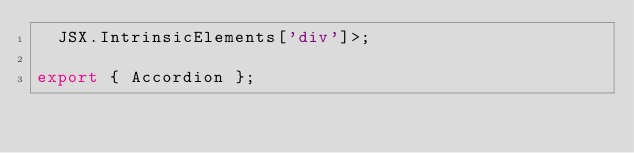Convert code to text. <code><loc_0><loc_0><loc_500><loc_500><_TypeScript_>  JSX.IntrinsicElements['div']>;

export { Accordion };
</code> 